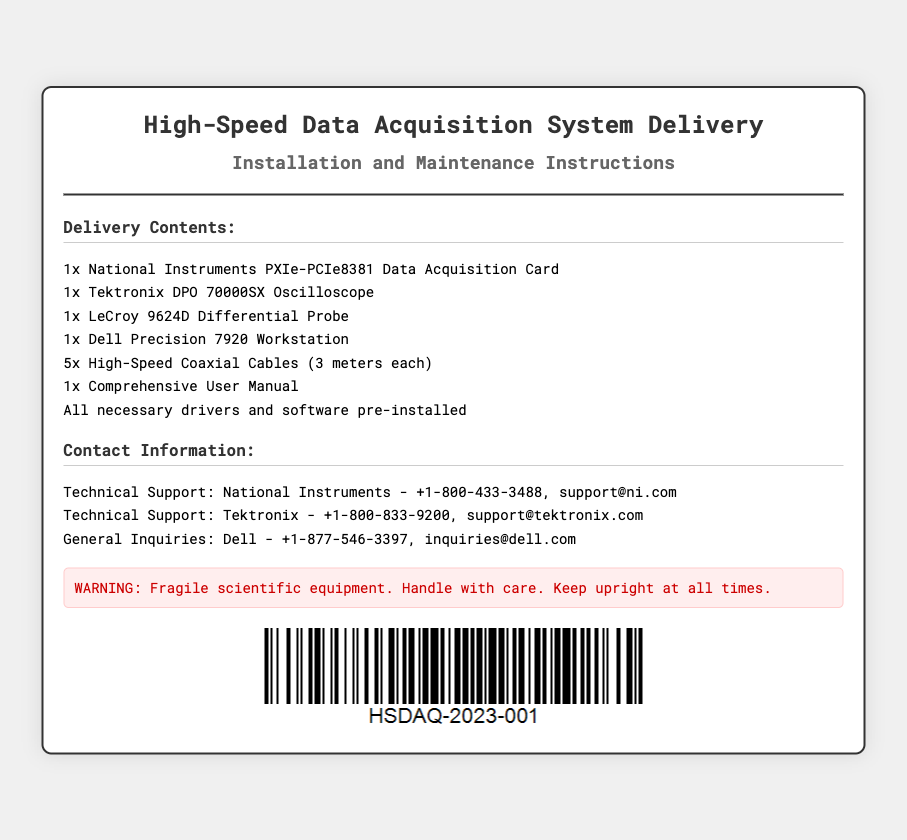What is the title of the document? The title appears at the top of the shipping label and provides the main subject of the document.
Answer: High-Speed Data Acquisition System Delivery What is the name of the first item listed in the delivery contents? The first item is critical to know as it often represents the main component of the system being delivered.
Answer: National Instruments PXIe-PCIe8381 Data Acquisition Card How many high-speed coaxial cables are included? This information is necessary to understand the quantity of cables provided for the equipment setup.
Answer: 5 Who should be contacted for technical support regarding the Tektronix equipment? Identifying the correct contact is important for users needing assistance with that specific manufacturer’s equipment.
Answer: Tektronix What is the warning associated with the delivery? This is a specific instruction regarding the handling of the equipment that users must follow to avoid damage.
Answer: Fragile scientific equipment. Handle with care What type of document is this? This categorization helps establish the purpose and content structure of the document.
Answer: Shipping label What should be kept upright at all times? This precaution helps in ensuring the integrity of the scientific equipment delivered.
Answer: Equipment What color is the text in the header? Recognizing the color scheme helps users understand the design and branding for clarity and visibility.
Answer: Dark gray 